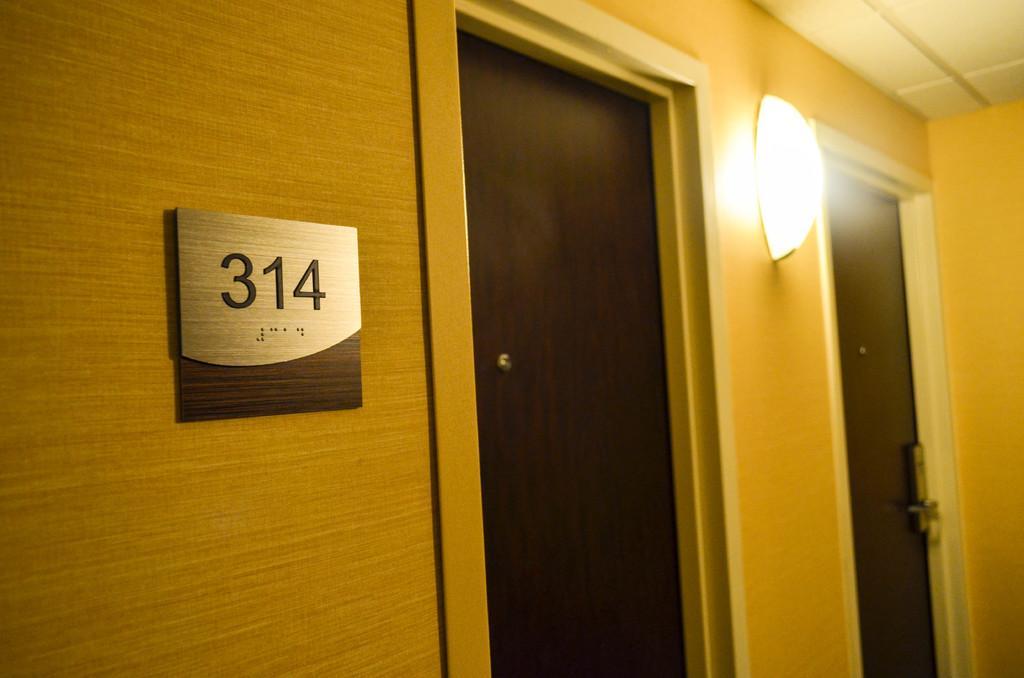In one or two sentences, can you explain what this image depicts? On the left side, there is a number board and a light attached to the wall and there are two doors. On the right side, there is a roof and there is a wall. 